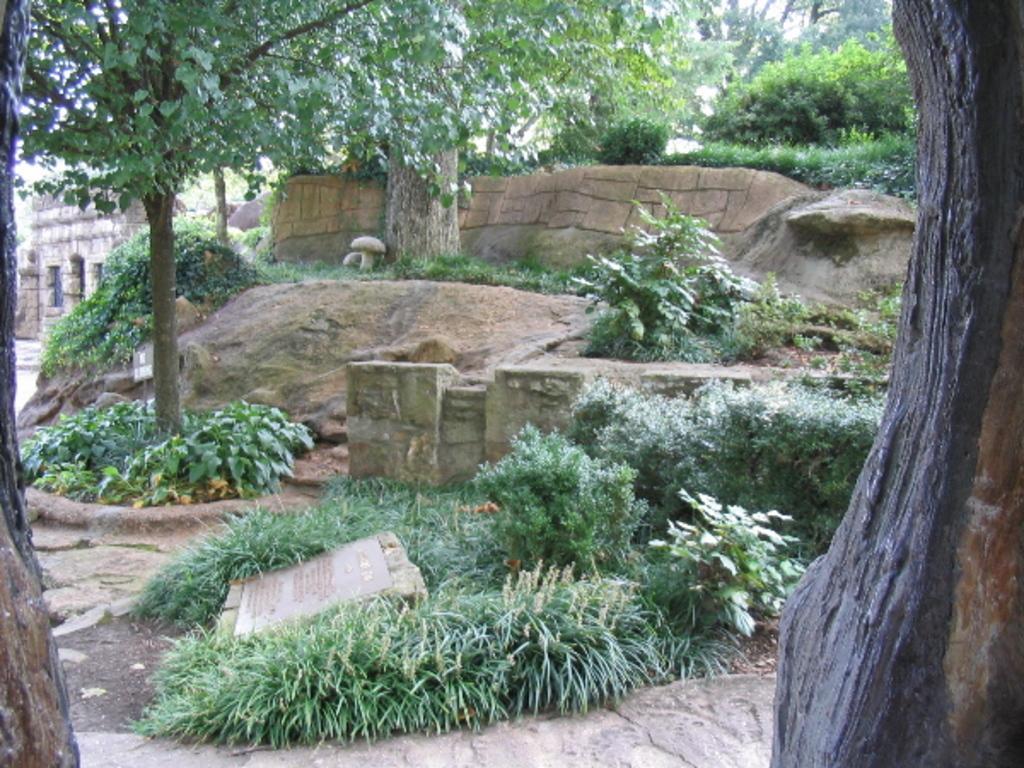Could you give a brief overview of what you see in this image? In this image we can see few plants, trees, a building, a stone with text on the ground. 